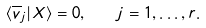<formula> <loc_0><loc_0><loc_500><loc_500>\langle \overline { v } _ { j } | X \rangle = 0 , \quad j = 1 , \dots , r .</formula> 